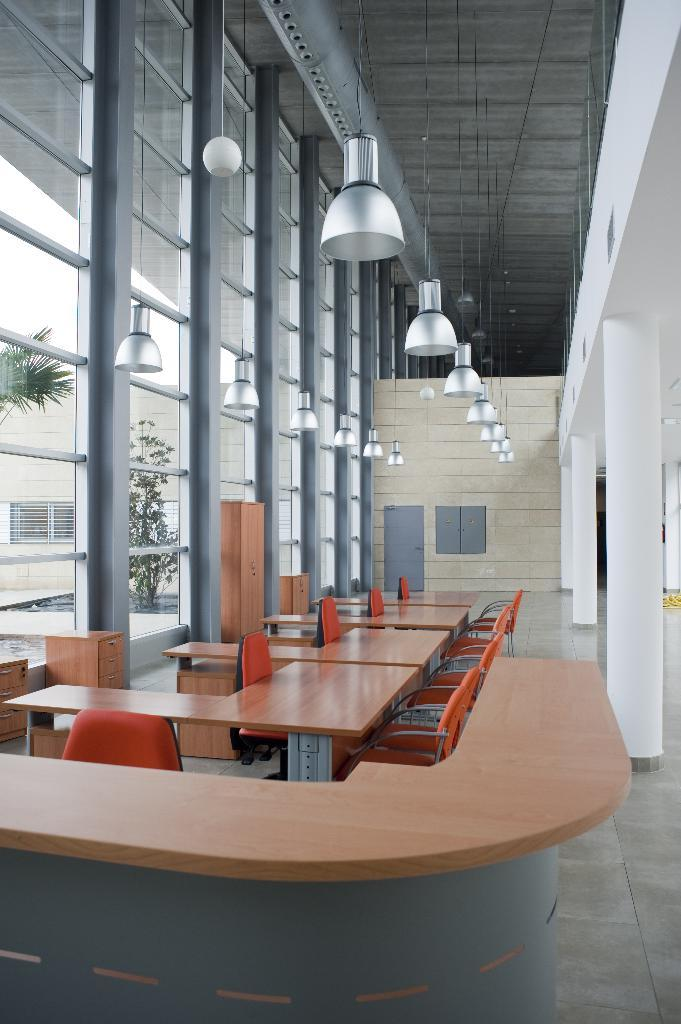What type of furniture is in the center of the image? There are chairs and tables in the center of the image. What can be seen on the left side of the image? There are windows on the left side of the image. What is located at the top side of the image? There are lamps at the top side of the image. What type of game is being played on the chairs in the image? There is no game being played in the image; it only shows chairs and tables. Can you see any crackers on the tables in the image? There is no mention of crackers in the image; it only shows chairs and tables. 